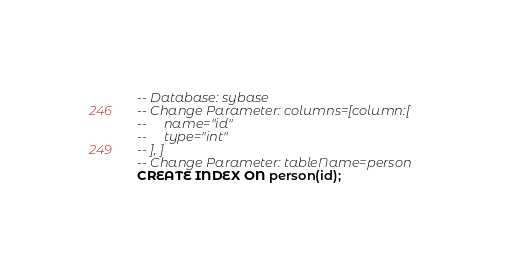Convert code to text. <code><loc_0><loc_0><loc_500><loc_500><_SQL_>-- Database: sybase
-- Change Parameter: columns=[column:[
--     name="id"
--     type="int"
-- ], ]
-- Change Parameter: tableName=person
CREATE INDEX ON person(id);
</code> 